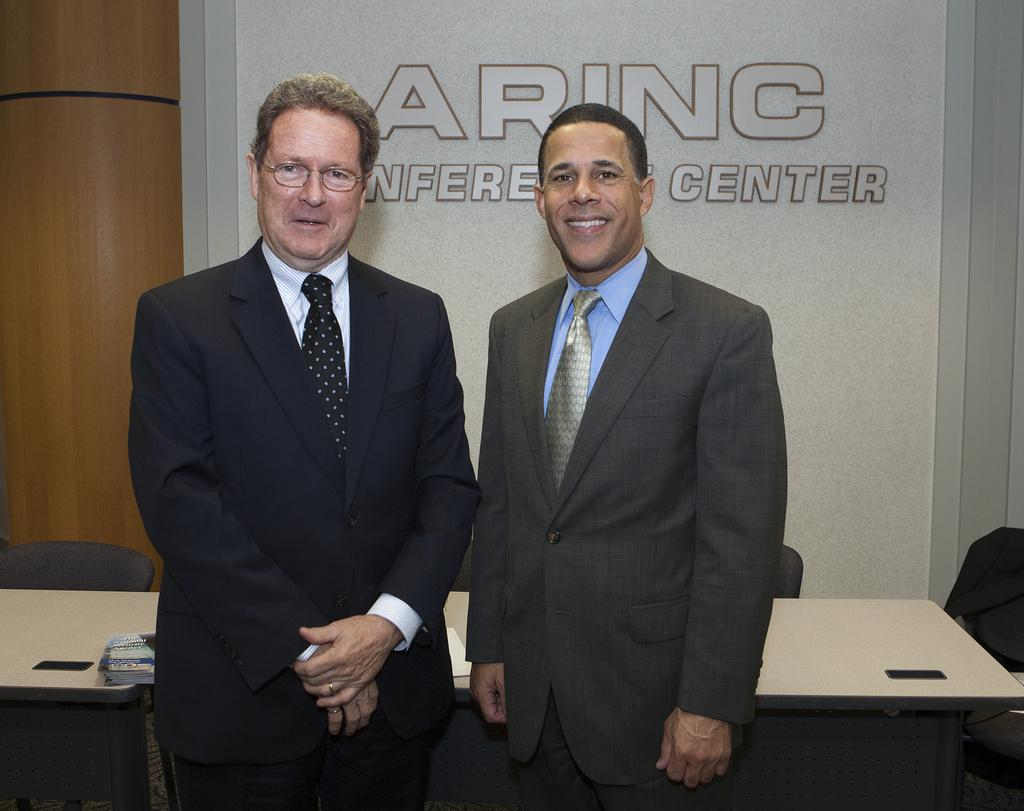What type of people can be seen in the image? There are men in the image. What type of furniture is present in the image? There are tables and chairs in the image. Can you describe the appearance of one person in the image? One person in the image is wearing spectacles. What is visible on the board in the background of the image? There is writing on the board in the background of the image. What type of twig is being used as a symbol of protest in the image? There is no twig or protest present in the image. What type of authority figure can be seen in the image? There is no authority figure present in the image. 